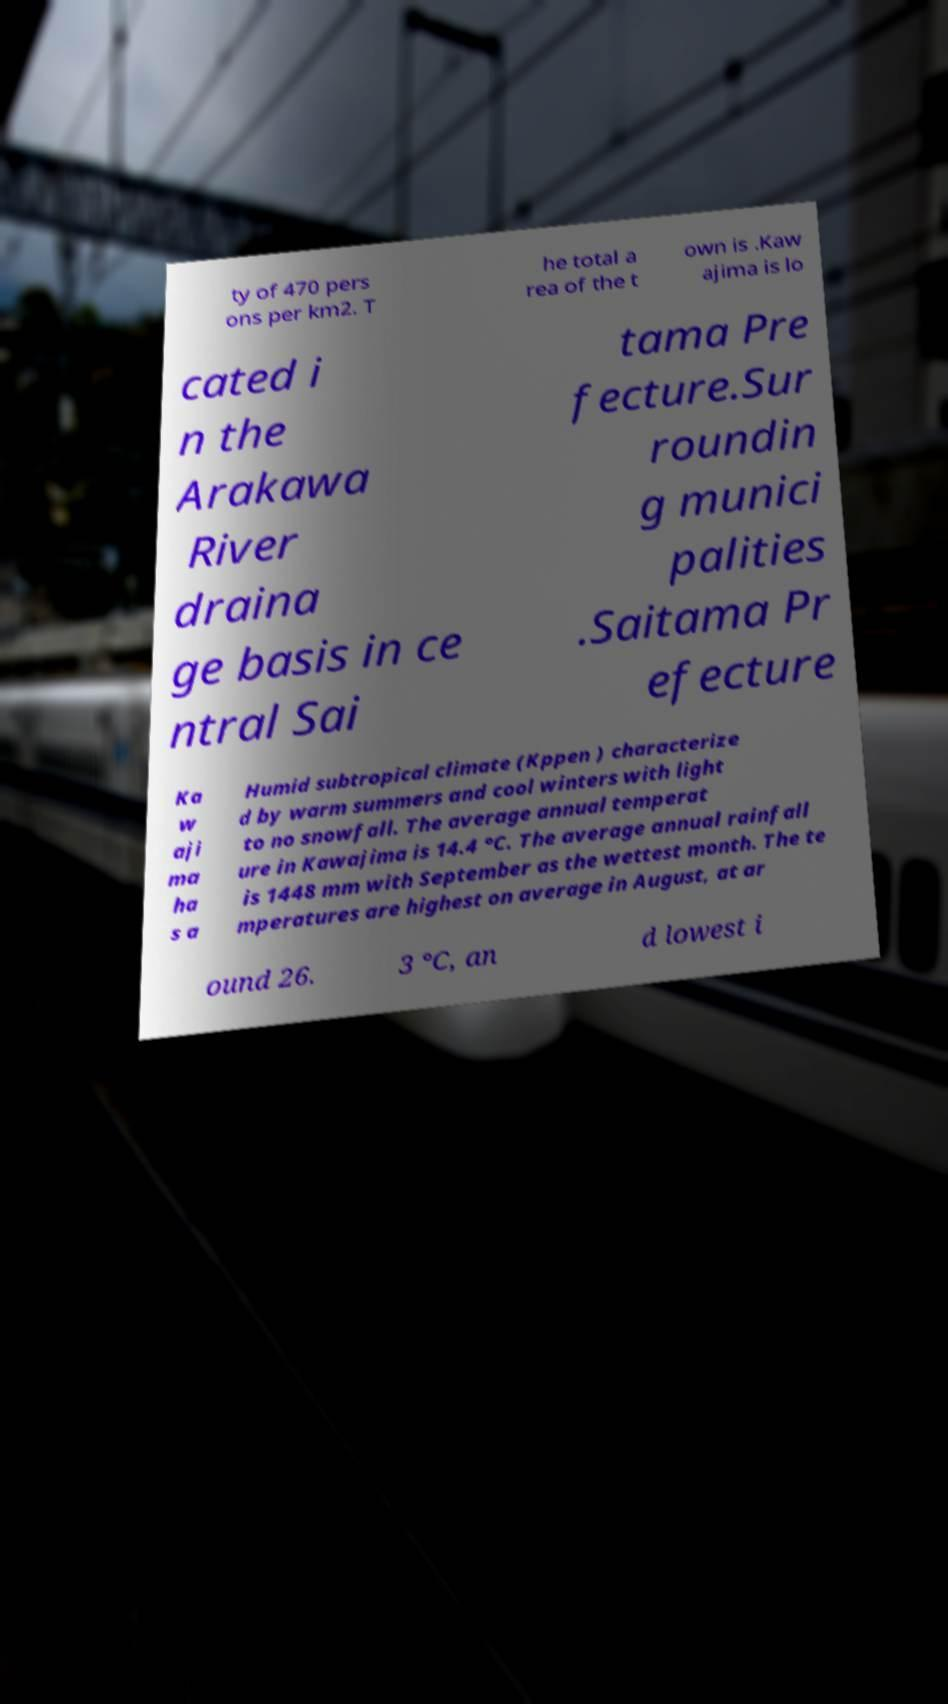Please read and relay the text visible in this image. What does it say? ty of 470 pers ons per km2. T he total a rea of the t own is .Kaw ajima is lo cated i n the Arakawa River draina ge basis in ce ntral Sai tama Pre fecture.Sur roundin g munici palities .Saitama Pr efecture Ka w aji ma ha s a Humid subtropical climate (Kppen ) characterize d by warm summers and cool winters with light to no snowfall. The average annual temperat ure in Kawajima is 14.4 °C. The average annual rainfall is 1448 mm with September as the wettest month. The te mperatures are highest on average in August, at ar ound 26. 3 °C, an d lowest i 